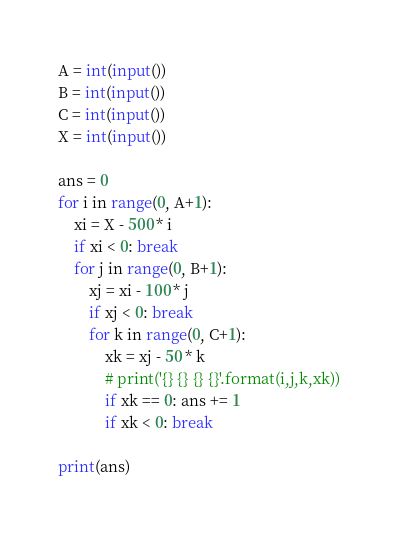<code> <loc_0><loc_0><loc_500><loc_500><_Python_>A = int(input())
B = int(input())
C = int(input())
X = int(input())

ans = 0
for i in range(0, A+1):
    xi = X - 500 * i
    if xi < 0: break
    for j in range(0, B+1):
        xj = xi - 100 * j
        if xj < 0: break
        for k in range(0, C+1):
            xk = xj - 50 * k
            # print('{} {} {} {}'.format(i,j,k,xk))
            if xk == 0: ans += 1
            if xk < 0: break

print(ans)</code> 